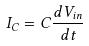<formula> <loc_0><loc_0><loc_500><loc_500>I _ { C } = C \frac { d V _ { i n } } { d t }</formula> 